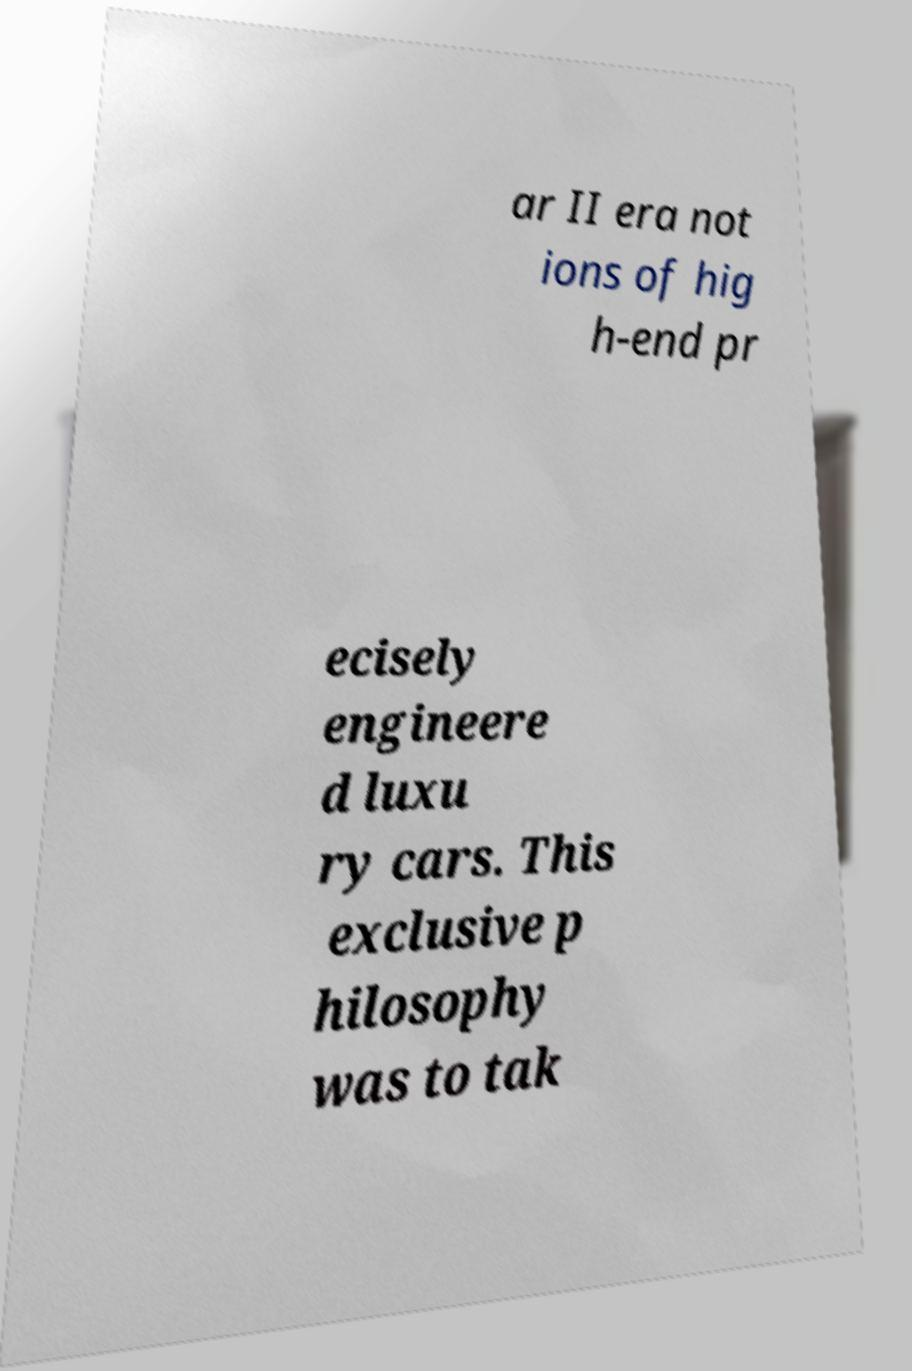I need the written content from this picture converted into text. Can you do that? ar II era not ions of hig h-end pr ecisely engineere d luxu ry cars. This exclusive p hilosophy was to tak 